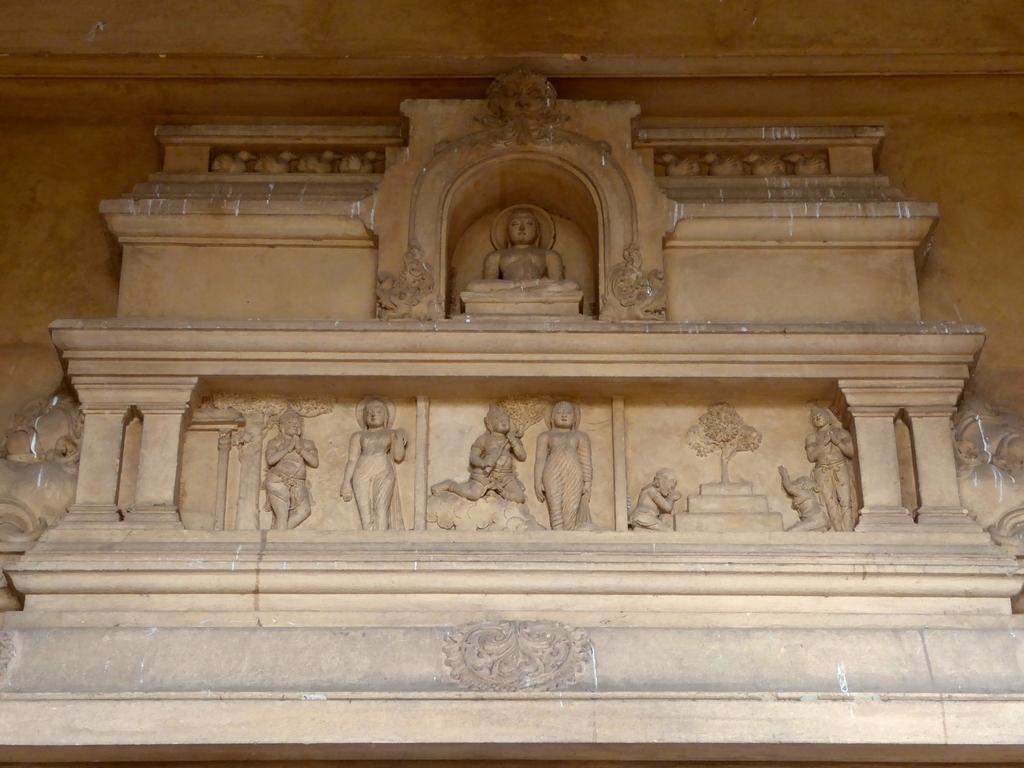In one or two sentences, can you explain what this image depicts? In this image in front there are sculptures. In the background of the image there is a wall. 